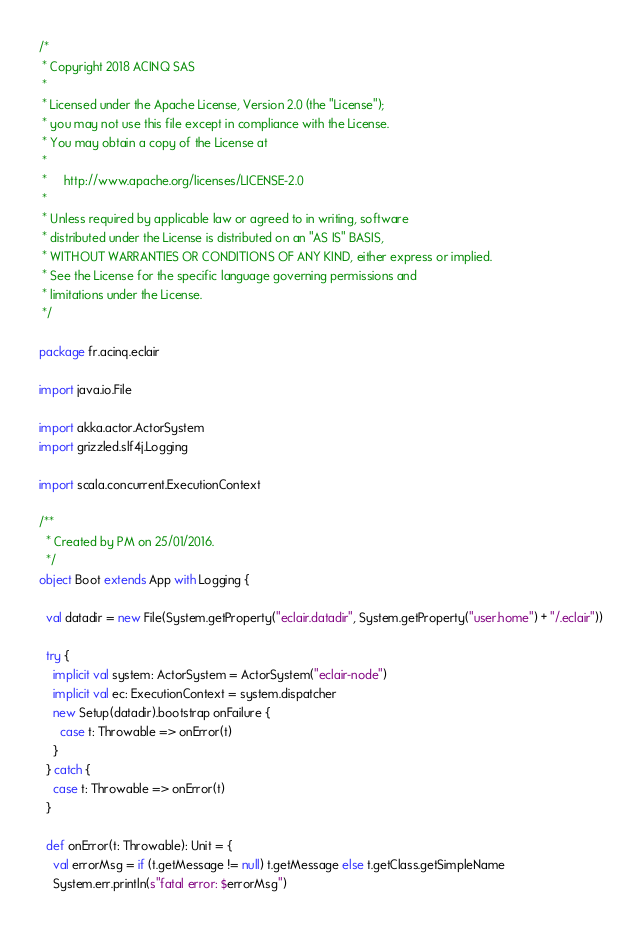Convert code to text. <code><loc_0><loc_0><loc_500><loc_500><_Scala_>/*
 * Copyright 2018 ACINQ SAS
 *
 * Licensed under the Apache License, Version 2.0 (the "License");
 * you may not use this file except in compliance with the License.
 * You may obtain a copy of the License at
 *
 *     http://www.apache.org/licenses/LICENSE-2.0
 *
 * Unless required by applicable law or agreed to in writing, software
 * distributed under the License is distributed on an "AS IS" BASIS,
 * WITHOUT WARRANTIES OR CONDITIONS OF ANY KIND, either express or implied.
 * See the License for the specific language governing permissions and
 * limitations under the License.
 */

package fr.acinq.eclair

import java.io.File

import akka.actor.ActorSystem
import grizzled.slf4j.Logging

import scala.concurrent.ExecutionContext

/**
  * Created by PM on 25/01/2016.
  */
object Boot extends App with Logging {

  val datadir = new File(System.getProperty("eclair.datadir", System.getProperty("user.home") + "/.eclair"))

  try {
    implicit val system: ActorSystem = ActorSystem("eclair-node")
    implicit val ec: ExecutionContext = system.dispatcher
    new Setup(datadir).bootstrap onFailure {
      case t: Throwable => onError(t)
    }
  } catch {
    case t: Throwable => onError(t)
  }

  def onError(t: Throwable): Unit = {
    val errorMsg = if (t.getMessage != null) t.getMessage else t.getClass.getSimpleName
    System.err.println(s"fatal error: $errorMsg")</code> 